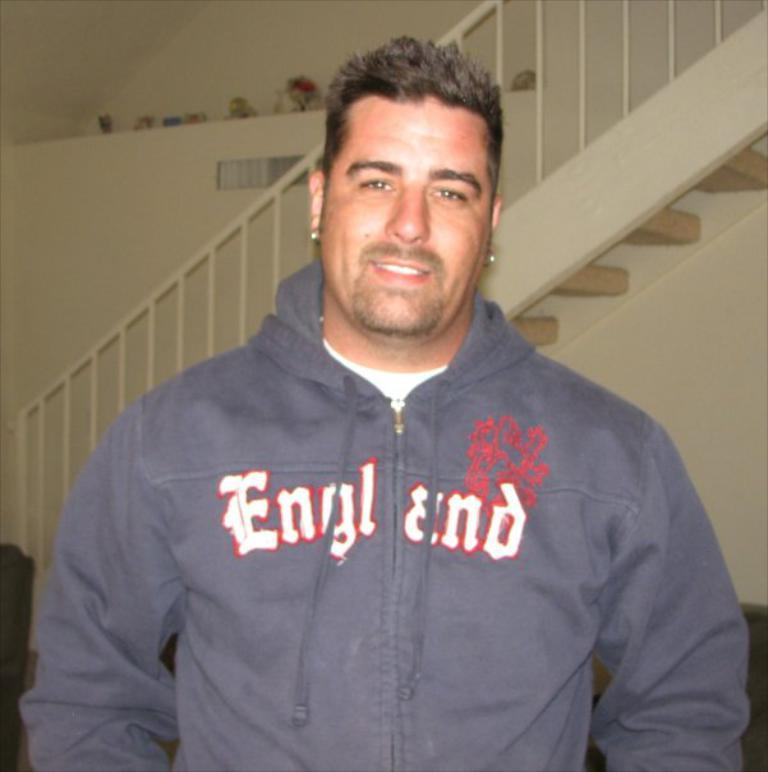What is the main subject of the image? There is a man in the image. What is the man wearing? The man is wearing a sweater. What architectural feature can be seen in the background of the image? There are stairs in the background of the image, and they have a railing associated with them. What else can be seen in the background of the image? There is a wall in the background of the image. What type of debt is the man discussing with the person off-camera in the image? There is no indication in the image that the man is discussing any type of debt, as the focus is on the man and his clothing, as well as the architectural features in the background. 